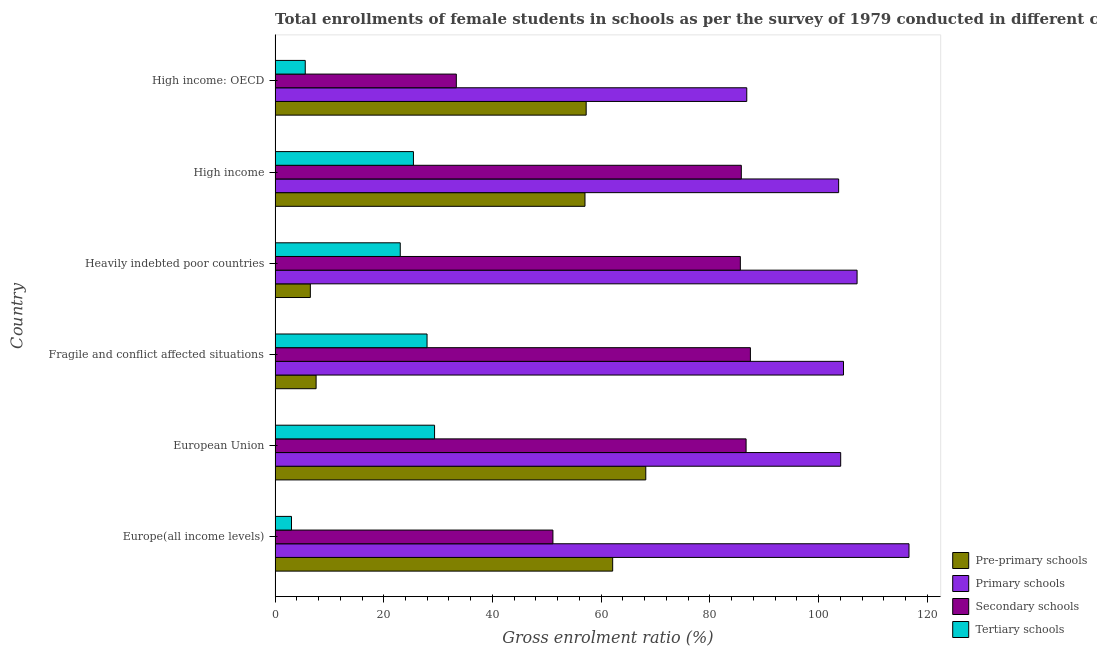Are the number of bars on each tick of the Y-axis equal?
Provide a short and direct response. Yes. How many bars are there on the 3rd tick from the bottom?
Give a very brief answer. 4. What is the label of the 4th group of bars from the top?
Ensure brevity in your answer.  Fragile and conflict affected situations. What is the gross enrolment ratio(female) in secondary schools in High income?
Ensure brevity in your answer.  85.79. Across all countries, what is the maximum gross enrolment ratio(female) in primary schools?
Give a very brief answer. 116.64. Across all countries, what is the minimum gross enrolment ratio(female) in pre-primary schools?
Keep it short and to the point. 6.49. In which country was the gross enrolment ratio(female) in primary schools minimum?
Provide a succinct answer. High income: OECD. What is the total gross enrolment ratio(female) in secondary schools in the graph?
Provide a succinct answer. 430.01. What is the difference between the gross enrolment ratio(female) in primary schools in Heavily indebted poor countries and that in High income?
Give a very brief answer. 3.39. What is the difference between the gross enrolment ratio(female) in secondary schools in High income: OECD and the gross enrolment ratio(female) in primary schools in Fragile and conflict affected situations?
Provide a succinct answer. -71.24. What is the average gross enrolment ratio(female) in pre-primary schools per country?
Provide a succinct answer. 43.11. What is the difference between the gross enrolment ratio(female) in secondary schools and gross enrolment ratio(female) in pre-primary schools in Heavily indebted poor countries?
Keep it short and to the point. 79.12. What is the ratio of the gross enrolment ratio(female) in pre-primary schools in Europe(all income levels) to that in Fragile and conflict affected situations?
Offer a terse response. 8.23. Is the difference between the gross enrolment ratio(female) in pre-primary schools in Fragile and conflict affected situations and High income greater than the difference between the gross enrolment ratio(female) in primary schools in Fragile and conflict affected situations and High income?
Your response must be concise. No. What is the difference between the highest and the second highest gross enrolment ratio(female) in pre-primary schools?
Your answer should be very brief. 6.09. What is the difference between the highest and the lowest gross enrolment ratio(female) in secondary schools?
Make the answer very short. 54.11. In how many countries, is the gross enrolment ratio(female) in secondary schools greater than the average gross enrolment ratio(female) in secondary schools taken over all countries?
Keep it short and to the point. 4. Is the sum of the gross enrolment ratio(female) in primary schools in Fragile and conflict affected situations and Heavily indebted poor countries greater than the maximum gross enrolment ratio(female) in tertiary schools across all countries?
Give a very brief answer. Yes. Is it the case that in every country, the sum of the gross enrolment ratio(female) in secondary schools and gross enrolment ratio(female) in tertiary schools is greater than the sum of gross enrolment ratio(female) in pre-primary schools and gross enrolment ratio(female) in primary schools?
Keep it short and to the point. No. What does the 4th bar from the top in Heavily indebted poor countries represents?
Offer a terse response. Pre-primary schools. What does the 2nd bar from the bottom in High income represents?
Provide a short and direct response. Primary schools. Is it the case that in every country, the sum of the gross enrolment ratio(female) in pre-primary schools and gross enrolment ratio(female) in primary schools is greater than the gross enrolment ratio(female) in secondary schools?
Offer a very short reply. Yes. What is the difference between two consecutive major ticks on the X-axis?
Give a very brief answer. 20. Does the graph contain any zero values?
Keep it short and to the point. No. Where does the legend appear in the graph?
Your answer should be compact. Bottom right. How many legend labels are there?
Make the answer very short. 4. How are the legend labels stacked?
Your answer should be very brief. Vertical. What is the title of the graph?
Provide a short and direct response. Total enrollments of female students in schools as per the survey of 1979 conducted in different countries. What is the label or title of the X-axis?
Offer a very short reply. Gross enrolment ratio (%). What is the Gross enrolment ratio (%) of Pre-primary schools in Europe(all income levels)?
Provide a short and direct response. 62.12. What is the Gross enrolment ratio (%) in Primary schools in Europe(all income levels)?
Your answer should be compact. 116.64. What is the Gross enrolment ratio (%) of Secondary schools in Europe(all income levels)?
Keep it short and to the point. 51.13. What is the Gross enrolment ratio (%) in Tertiary schools in Europe(all income levels)?
Provide a short and direct response. 3.02. What is the Gross enrolment ratio (%) of Pre-primary schools in European Union?
Keep it short and to the point. 68.21. What is the Gross enrolment ratio (%) of Primary schools in European Union?
Ensure brevity in your answer.  104.08. What is the Gross enrolment ratio (%) of Secondary schools in European Union?
Keep it short and to the point. 86.67. What is the Gross enrolment ratio (%) in Tertiary schools in European Union?
Keep it short and to the point. 29.34. What is the Gross enrolment ratio (%) in Pre-primary schools in Fragile and conflict affected situations?
Your answer should be very brief. 7.55. What is the Gross enrolment ratio (%) of Primary schools in Fragile and conflict affected situations?
Ensure brevity in your answer.  104.59. What is the Gross enrolment ratio (%) of Secondary schools in Fragile and conflict affected situations?
Make the answer very short. 87.46. What is the Gross enrolment ratio (%) of Tertiary schools in Fragile and conflict affected situations?
Make the answer very short. 27.96. What is the Gross enrolment ratio (%) of Pre-primary schools in Heavily indebted poor countries?
Ensure brevity in your answer.  6.49. What is the Gross enrolment ratio (%) of Primary schools in Heavily indebted poor countries?
Your answer should be very brief. 107.09. What is the Gross enrolment ratio (%) of Secondary schools in Heavily indebted poor countries?
Offer a very short reply. 85.61. What is the Gross enrolment ratio (%) of Tertiary schools in Heavily indebted poor countries?
Make the answer very short. 23.03. What is the Gross enrolment ratio (%) in Pre-primary schools in High income?
Your answer should be compact. 57.02. What is the Gross enrolment ratio (%) in Primary schools in High income?
Provide a short and direct response. 103.7. What is the Gross enrolment ratio (%) of Secondary schools in High income?
Provide a short and direct response. 85.79. What is the Gross enrolment ratio (%) of Tertiary schools in High income?
Ensure brevity in your answer.  25.46. What is the Gross enrolment ratio (%) of Pre-primary schools in High income: OECD?
Give a very brief answer. 57.24. What is the Gross enrolment ratio (%) of Primary schools in High income: OECD?
Keep it short and to the point. 86.79. What is the Gross enrolment ratio (%) in Secondary schools in High income: OECD?
Your answer should be very brief. 33.35. What is the Gross enrolment ratio (%) in Tertiary schools in High income: OECD?
Offer a very short reply. 5.55. Across all countries, what is the maximum Gross enrolment ratio (%) of Pre-primary schools?
Your answer should be compact. 68.21. Across all countries, what is the maximum Gross enrolment ratio (%) in Primary schools?
Offer a very short reply. 116.64. Across all countries, what is the maximum Gross enrolment ratio (%) of Secondary schools?
Keep it short and to the point. 87.46. Across all countries, what is the maximum Gross enrolment ratio (%) of Tertiary schools?
Provide a succinct answer. 29.34. Across all countries, what is the minimum Gross enrolment ratio (%) in Pre-primary schools?
Ensure brevity in your answer.  6.49. Across all countries, what is the minimum Gross enrolment ratio (%) in Primary schools?
Keep it short and to the point. 86.79. Across all countries, what is the minimum Gross enrolment ratio (%) in Secondary schools?
Your response must be concise. 33.35. Across all countries, what is the minimum Gross enrolment ratio (%) in Tertiary schools?
Provide a short and direct response. 3.02. What is the total Gross enrolment ratio (%) of Pre-primary schools in the graph?
Keep it short and to the point. 258.64. What is the total Gross enrolment ratio (%) in Primary schools in the graph?
Give a very brief answer. 622.9. What is the total Gross enrolment ratio (%) of Secondary schools in the graph?
Your answer should be compact. 430.01. What is the total Gross enrolment ratio (%) in Tertiary schools in the graph?
Your response must be concise. 114.37. What is the difference between the Gross enrolment ratio (%) of Pre-primary schools in Europe(all income levels) and that in European Union?
Offer a terse response. -6.09. What is the difference between the Gross enrolment ratio (%) of Primary schools in Europe(all income levels) and that in European Union?
Provide a short and direct response. 12.57. What is the difference between the Gross enrolment ratio (%) in Secondary schools in Europe(all income levels) and that in European Union?
Ensure brevity in your answer.  -35.54. What is the difference between the Gross enrolment ratio (%) in Tertiary schools in Europe(all income levels) and that in European Union?
Ensure brevity in your answer.  -26.32. What is the difference between the Gross enrolment ratio (%) in Pre-primary schools in Europe(all income levels) and that in Fragile and conflict affected situations?
Give a very brief answer. 54.57. What is the difference between the Gross enrolment ratio (%) of Primary schools in Europe(all income levels) and that in Fragile and conflict affected situations?
Your answer should be very brief. 12.05. What is the difference between the Gross enrolment ratio (%) in Secondary schools in Europe(all income levels) and that in Fragile and conflict affected situations?
Give a very brief answer. -36.34. What is the difference between the Gross enrolment ratio (%) in Tertiary schools in Europe(all income levels) and that in Fragile and conflict affected situations?
Provide a succinct answer. -24.94. What is the difference between the Gross enrolment ratio (%) of Pre-primary schools in Europe(all income levels) and that in Heavily indebted poor countries?
Your response must be concise. 55.63. What is the difference between the Gross enrolment ratio (%) of Primary schools in Europe(all income levels) and that in Heavily indebted poor countries?
Your answer should be very brief. 9.55. What is the difference between the Gross enrolment ratio (%) in Secondary schools in Europe(all income levels) and that in Heavily indebted poor countries?
Offer a very short reply. -34.48. What is the difference between the Gross enrolment ratio (%) of Tertiary schools in Europe(all income levels) and that in Heavily indebted poor countries?
Provide a short and direct response. -20.01. What is the difference between the Gross enrolment ratio (%) of Pre-primary schools in Europe(all income levels) and that in High income?
Provide a succinct answer. 5.1. What is the difference between the Gross enrolment ratio (%) in Primary schools in Europe(all income levels) and that in High income?
Keep it short and to the point. 12.95. What is the difference between the Gross enrolment ratio (%) in Secondary schools in Europe(all income levels) and that in High income?
Offer a very short reply. -34.66. What is the difference between the Gross enrolment ratio (%) in Tertiary schools in Europe(all income levels) and that in High income?
Offer a very short reply. -22.44. What is the difference between the Gross enrolment ratio (%) in Pre-primary schools in Europe(all income levels) and that in High income: OECD?
Offer a very short reply. 4.88. What is the difference between the Gross enrolment ratio (%) in Primary schools in Europe(all income levels) and that in High income: OECD?
Your answer should be compact. 29.85. What is the difference between the Gross enrolment ratio (%) of Secondary schools in Europe(all income levels) and that in High income: OECD?
Make the answer very short. 17.78. What is the difference between the Gross enrolment ratio (%) in Tertiary schools in Europe(all income levels) and that in High income: OECD?
Your answer should be very brief. -2.53. What is the difference between the Gross enrolment ratio (%) in Pre-primary schools in European Union and that in Fragile and conflict affected situations?
Make the answer very short. 60.66. What is the difference between the Gross enrolment ratio (%) of Primary schools in European Union and that in Fragile and conflict affected situations?
Make the answer very short. -0.52. What is the difference between the Gross enrolment ratio (%) in Secondary schools in European Union and that in Fragile and conflict affected situations?
Your response must be concise. -0.79. What is the difference between the Gross enrolment ratio (%) of Tertiary schools in European Union and that in Fragile and conflict affected situations?
Keep it short and to the point. 1.38. What is the difference between the Gross enrolment ratio (%) in Pre-primary schools in European Union and that in Heavily indebted poor countries?
Your answer should be compact. 61.72. What is the difference between the Gross enrolment ratio (%) of Primary schools in European Union and that in Heavily indebted poor countries?
Ensure brevity in your answer.  -3.02. What is the difference between the Gross enrolment ratio (%) of Secondary schools in European Union and that in Heavily indebted poor countries?
Offer a very short reply. 1.06. What is the difference between the Gross enrolment ratio (%) of Tertiary schools in European Union and that in Heavily indebted poor countries?
Provide a short and direct response. 6.31. What is the difference between the Gross enrolment ratio (%) in Pre-primary schools in European Union and that in High income?
Your answer should be very brief. 11.19. What is the difference between the Gross enrolment ratio (%) in Primary schools in European Union and that in High income?
Your answer should be very brief. 0.38. What is the difference between the Gross enrolment ratio (%) in Secondary schools in European Union and that in High income?
Offer a very short reply. 0.88. What is the difference between the Gross enrolment ratio (%) of Tertiary schools in European Union and that in High income?
Offer a terse response. 3.89. What is the difference between the Gross enrolment ratio (%) of Pre-primary schools in European Union and that in High income: OECD?
Ensure brevity in your answer.  10.97. What is the difference between the Gross enrolment ratio (%) of Primary schools in European Union and that in High income: OECD?
Offer a terse response. 17.28. What is the difference between the Gross enrolment ratio (%) of Secondary schools in European Union and that in High income: OECD?
Your answer should be compact. 53.32. What is the difference between the Gross enrolment ratio (%) of Tertiary schools in European Union and that in High income: OECD?
Make the answer very short. 23.79. What is the difference between the Gross enrolment ratio (%) in Pre-primary schools in Fragile and conflict affected situations and that in Heavily indebted poor countries?
Provide a short and direct response. 1.06. What is the difference between the Gross enrolment ratio (%) of Primary schools in Fragile and conflict affected situations and that in Heavily indebted poor countries?
Your response must be concise. -2.5. What is the difference between the Gross enrolment ratio (%) in Secondary schools in Fragile and conflict affected situations and that in Heavily indebted poor countries?
Provide a succinct answer. 1.85. What is the difference between the Gross enrolment ratio (%) of Tertiary schools in Fragile and conflict affected situations and that in Heavily indebted poor countries?
Offer a very short reply. 4.93. What is the difference between the Gross enrolment ratio (%) of Pre-primary schools in Fragile and conflict affected situations and that in High income?
Your answer should be very brief. -49.48. What is the difference between the Gross enrolment ratio (%) of Primary schools in Fragile and conflict affected situations and that in High income?
Provide a short and direct response. 0.89. What is the difference between the Gross enrolment ratio (%) in Secondary schools in Fragile and conflict affected situations and that in High income?
Offer a very short reply. 1.67. What is the difference between the Gross enrolment ratio (%) of Tertiary schools in Fragile and conflict affected situations and that in High income?
Your answer should be compact. 2.5. What is the difference between the Gross enrolment ratio (%) of Pre-primary schools in Fragile and conflict affected situations and that in High income: OECD?
Provide a succinct answer. -49.69. What is the difference between the Gross enrolment ratio (%) in Primary schools in Fragile and conflict affected situations and that in High income: OECD?
Give a very brief answer. 17.8. What is the difference between the Gross enrolment ratio (%) in Secondary schools in Fragile and conflict affected situations and that in High income: OECD?
Offer a very short reply. 54.11. What is the difference between the Gross enrolment ratio (%) in Tertiary schools in Fragile and conflict affected situations and that in High income: OECD?
Your answer should be compact. 22.41. What is the difference between the Gross enrolment ratio (%) of Pre-primary schools in Heavily indebted poor countries and that in High income?
Give a very brief answer. -50.54. What is the difference between the Gross enrolment ratio (%) of Primary schools in Heavily indebted poor countries and that in High income?
Ensure brevity in your answer.  3.39. What is the difference between the Gross enrolment ratio (%) in Secondary schools in Heavily indebted poor countries and that in High income?
Make the answer very short. -0.18. What is the difference between the Gross enrolment ratio (%) of Tertiary schools in Heavily indebted poor countries and that in High income?
Keep it short and to the point. -2.43. What is the difference between the Gross enrolment ratio (%) in Pre-primary schools in Heavily indebted poor countries and that in High income: OECD?
Your answer should be very brief. -50.75. What is the difference between the Gross enrolment ratio (%) in Primary schools in Heavily indebted poor countries and that in High income: OECD?
Keep it short and to the point. 20.3. What is the difference between the Gross enrolment ratio (%) of Secondary schools in Heavily indebted poor countries and that in High income: OECD?
Ensure brevity in your answer.  52.26. What is the difference between the Gross enrolment ratio (%) in Tertiary schools in Heavily indebted poor countries and that in High income: OECD?
Make the answer very short. 17.48. What is the difference between the Gross enrolment ratio (%) in Pre-primary schools in High income and that in High income: OECD?
Give a very brief answer. -0.22. What is the difference between the Gross enrolment ratio (%) of Primary schools in High income and that in High income: OECD?
Provide a succinct answer. 16.91. What is the difference between the Gross enrolment ratio (%) of Secondary schools in High income and that in High income: OECD?
Ensure brevity in your answer.  52.44. What is the difference between the Gross enrolment ratio (%) in Tertiary schools in High income and that in High income: OECD?
Provide a succinct answer. 19.91. What is the difference between the Gross enrolment ratio (%) in Pre-primary schools in Europe(all income levels) and the Gross enrolment ratio (%) in Primary schools in European Union?
Give a very brief answer. -41.96. What is the difference between the Gross enrolment ratio (%) of Pre-primary schools in Europe(all income levels) and the Gross enrolment ratio (%) of Secondary schools in European Union?
Your answer should be very brief. -24.55. What is the difference between the Gross enrolment ratio (%) in Pre-primary schools in Europe(all income levels) and the Gross enrolment ratio (%) in Tertiary schools in European Union?
Keep it short and to the point. 32.78. What is the difference between the Gross enrolment ratio (%) in Primary schools in Europe(all income levels) and the Gross enrolment ratio (%) in Secondary schools in European Union?
Provide a short and direct response. 29.98. What is the difference between the Gross enrolment ratio (%) of Primary schools in Europe(all income levels) and the Gross enrolment ratio (%) of Tertiary schools in European Union?
Your answer should be very brief. 87.3. What is the difference between the Gross enrolment ratio (%) in Secondary schools in Europe(all income levels) and the Gross enrolment ratio (%) in Tertiary schools in European Union?
Your answer should be very brief. 21.78. What is the difference between the Gross enrolment ratio (%) of Pre-primary schools in Europe(all income levels) and the Gross enrolment ratio (%) of Primary schools in Fragile and conflict affected situations?
Ensure brevity in your answer.  -42.47. What is the difference between the Gross enrolment ratio (%) of Pre-primary schools in Europe(all income levels) and the Gross enrolment ratio (%) of Secondary schools in Fragile and conflict affected situations?
Provide a short and direct response. -25.34. What is the difference between the Gross enrolment ratio (%) of Pre-primary schools in Europe(all income levels) and the Gross enrolment ratio (%) of Tertiary schools in Fragile and conflict affected situations?
Make the answer very short. 34.16. What is the difference between the Gross enrolment ratio (%) of Primary schools in Europe(all income levels) and the Gross enrolment ratio (%) of Secondary schools in Fragile and conflict affected situations?
Your answer should be compact. 29.18. What is the difference between the Gross enrolment ratio (%) in Primary schools in Europe(all income levels) and the Gross enrolment ratio (%) in Tertiary schools in Fragile and conflict affected situations?
Keep it short and to the point. 88.68. What is the difference between the Gross enrolment ratio (%) in Secondary schools in Europe(all income levels) and the Gross enrolment ratio (%) in Tertiary schools in Fragile and conflict affected situations?
Your answer should be very brief. 23.16. What is the difference between the Gross enrolment ratio (%) in Pre-primary schools in Europe(all income levels) and the Gross enrolment ratio (%) in Primary schools in Heavily indebted poor countries?
Give a very brief answer. -44.97. What is the difference between the Gross enrolment ratio (%) in Pre-primary schools in Europe(all income levels) and the Gross enrolment ratio (%) in Secondary schools in Heavily indebted poor countries?
Your response must be concise. -23.49. What is the difference between the Gross enrolment ratio (%) in Pre-primary schools in Europe(all income levels) and the Gross enrolment ratio (%) in Tertiary schools in Heavily indebted poor countries?
Provide a short and direct response. 39.09. What is the difference between the Gross enrolment ratio (%) in Primary schools in Europe(all income levels) and the Gross enrolment ratio (%) in Secondary schools in Heavily indebted poor countries?
Your answer should be compact. 31.03. What is the difference between the Gross enrolment ratio (%) of Primary schools in Europe(all income levels) and the Gross enrolment ratio (%) of Tertiary schools in Heavily indebted poor countries?
Offer a very short reply. 93.61. What is the difference between the Gross enrolment ratio (%) in Secondary schools in Europe(all income levels) and the Gross enrolment ratio (%) in Tertiary schools in Heavily indebted poor countries?
Offer a terse response. 28.09. What is the difference between the Gross enrolment ratio (%) in Pre-primary schools in Europe(all income levels) and the Gross enrolment ratio (%) in Primary schools in High income?
Your answer should be very brief. -41.58. What is the difference between the Gross enrolment ratio (%) in Pre-primary schools in Europe(all income levels) and the Gross enrolment ratio (%) in Secondary schools in High income?
Your answer should be very brief. -23.67. What is the difference between the Gross enrolment ratio (%) in Pre-primary schools in Europe(all income levels) and the Gross enrolment ratio (%) in Tertiary schools in High income?
Your answer should be very brief. 36.66. What is the difference between the Gross enrolment ratio (%) in Primary schools in Europe(all income levels) and the Gross enrolment ratio (%) in Secondary schools in High income?
Provide a succinct answer. 30.86. What is the difference between the Gross enrolment ratio (%) in Primary schools in Europe(all income levels) and the Gross enrolment ratio (%) in Tertiary schools in High income?
Make the answer very short. 91.19. What is the difference between the Gross enrolment ratio (%) of Secondary schools in Europe(all income levels) and the Gross enrolment ratio (%) of Tertiary schools in High income?
Make the answer very short. 25.67. What is the difference between the Gross enrolment ratio (%) in Pre-primary schools in Europe(all income levels) and the Gross enrolment ratio (%) in Primary schools in High income: OECD?
Offer a terse response. -24.67. What is the difference between the Gross enrolment ratio (%) in Pre-primary schools in Europe(all income levels) and the Gross enrolment ratio (%) in Secondary schools in High income: OECD?
Keep it short and to the point. 28.77. What is the difference between the Gross enrolment ratio (%) in Pre-primary schools in Europe(all income levels) and the Gross enrolment ratio (%) in Tertiary schools in High income: OECD?
Offer a terse response. 56.57. What is the difference between the Gross enrolment ratio (%) of Primary schools in Europe(all income levels) and the Gross enrolment ratio (%) of Secondary schools in High income: OECD?
Your answer should be compact. 83.3. What is the difference between the Gross enrolment ratio (%) of Primary schools in Europe(all income levels) and the Gross enrolment ratio (%) of Tertiary schools in High income: OECD?
Keep it short and to the point. 111.09. What is the difference between the Gross enrolment ratio (%) in Secondary schools in Europe(all income levels) and the Gross enrolment ratio (%) in Tertiary schools in High income: OECD?
Keep it short and to the point. 45.57. What is the difference between the Gross enrolment ratio (%) of Pre-primary schools in European Union and the Gross enrolment ratio (%) of Primary schools in Fragile and conflict affected situations?
Offer a very short reply. -36.38. What is the difference between the Gross enrolment ratio (%) of Pre-primary schools in European Union and the Gross enrolment ratio (%) of Secondary schools in Fragile and conflict affected situations?
Your answer should be compact. -19.25. What is the difference between the Gross enrolment ratio (%) in Pre-primary schools in European Union and the Gross enrolment ratio (%) in Tertiary schools in Fragile and conflict affected situations?
Your response must be concise. 40.25. What is the difference between the Gross enrolment ratio (%) of Primary schools in European Union and the Gross enrolment ratio (%) of Secondary schools in Fragile and conflict affected situations?
Your response must be concise. 16.61. What is the difference between the Gross enrolment ratio (%) of Primary schools in European Union and the Gross enrolment ratio (%) of Tertiary schools in Fragile and conflict affected situations?
Provide a succinct answer. 76.11. What is the difference between the Gross enrolment ratio (%) in Secondary schools in European Union and the Gross enrolment ratio (%) in Tertiary schools in Fragile and conflict affected situations?
Offer a very short reply. 58.7. What is the difference between the Gross enrolment ratio (%) in Pre-primary schools in European Union and the Gross enrolment ratio (%) in Primary schools in Heavily indebted poor countries?
Give a very brief answer. -38.88. What is the difference between the Gross enrolment ratio (%) of Pre-primary schools in European Union and the Gross enrolment ratio (%) of Secondary schools in Heavily indebted poor countries?
Offer a terse response. -17.4. What is the difference between the Gross enrolment ratio (%) of Pre-primary schools in European Union and the Gross enrolment ratio (%) of Tertiary schools in Heavily indebted poor countries?
Offer a terse response. 45.18. What is the difference between the Gross enrolment ratio (%) of Primary schools in European Union and the Gross enrolment ratio (%) of Secondary schools in Heavily indebted poor countries?
Make the answer very short. 18.46. What is the difference between the Gross enrolment ratio (%) of Primary schools in European Union and the Gross enrolment ratio (%) of Tertiary schools in Heavily indebted poor countries?
Your response must be concise. 81.04. What is the difference between the Gross enrolment ratio (%) of Secondary schools in European Union and the Gross enrolment ratio (%) of Tertiary schools in Heavily indebted poor countries?
Ensure brevity in your answer.  63.64. What is the difference between the Gross enrolment ratio (%) in Pre-primary schools in European Union and the Gross enrolment ratio (%) in Primary schools in High income?
Offer a very short reply. -35.49. What is the difference between the Gross enrolment ratio (%) of Pre-primary schools in European Union and the Gross enrolment ratio (%) of Secondary schools in High income?
Make the answer very short. -17.58. What is the difference between the Gross enrolment ratio (%) of Pre-primary schools in European Union and the Gross enrolment ratio (%) of Tertiary schools in High income?
Offer a terse response. 42.75. What is the difference between the Gross enrolment ratio (%) in Primary schools in European Union and the Gross enrolment ratio (%) in Secondary schools in High income?
Your response must be concise. 18.29. What is the difference between the Gross enrolment ratio (%) of Primary schools in European Union and the Gross enrolment ratio (%) of Tertiary schools in High income?
Give a very brief answer. 78.62. What is the difference between the Gross enrolment ratio (%) in Secondary schools in European Union and the Gross enrolment ratio (%) in Tertiary schools in High income?
Offer a terse response. 61.21. What is the difference between the Gross enrolment ratio (%) of Pre-primary schools in European Union and the Gross enrolment ratio (%) of Primary schools in High income: OECD?
Give a very brief answer. -18.58. What is the difference between the Gross enrolment ratio (%) of Pre-primary schools in European Union and the Gross enrolment ratio (%) of Secondary schools in High income: OECD?
Offer a terse response. 34.86. What is the difference between the Gross enrolment ratio (%) in Pre-primary schools in European Union and the Gross enrolment ratio (%) in Tertiary schools in High income: OECD?
Make the answer very short. 62.66. What is the difference between the Gross enrolment ratio (%) of Primary schools in European Union and the Gross enrolment ratio (%) of Secondary schools in High income: OECD?
Provide a succinct answer. 70.73. What is the difference between the Gross enrolment ratio (%) of Primary schools in European Union and the Gross enrolment ratio (%) of Tertiary schools in High income: OECD?
Offer a very short reply. 98.52. What is the difference between the Gross enrolment ratio (%) of Secondary schools in European Union and the Gross enrolment ratio (%) of Tertiary schools in High income: OECD?
Your answer should be very brief. 81.12. What is the difference between the Gross enrolment ratio (%) of Pre-primary schools in Fragile and conflict affected situations and the Gross enrolment ratio (%) of Primary schools in Heavily indebted poor countries?
Provide a succinct answer. -99.54. What is the difference between the Gross enrolment ratio (%) in Pre-primary schools in Fragile and conflict affected situations and the Gross enrolment ratio (%) in Secondary schools in Heavily indebted poor countries?
Give a very brief answer. -78.06. What is the difference between the Gross enrolment ratio (%) in Pre-primary schools in Fragile and conflict affected situations and the Gross enrolment ratio (%) in Tertiary schools in Heavily indebted poor countries?
Keep it short and to the point. -15.48. What is the difference between the Gross enrolment ratio (%) in Primary schools in Fragile and conflict affected situations and the Gross enrolment ratio (%) in Secondary schools in Heavily indebted poor countries?
Your response must be concise. 18.98. What is the difference between the Gross enrolment ratio (%) of Primary schools in Fragile and conflict affected situations and the Gross enrolment ratio (%) of Tertiary schools in Heavily indebted poor countries?
Your response must be concise. 81.56. What is the difference between the Gross enrolment ratio (%) in Secondary schools in Fragile and conflict affected situations and the Gross enrolment ratio (%) in Tertiary schools in Heavily indebted poor countries?
Offer a very short reply. 64.43. What is the difference between the Gross enrolment ratio (%) of Pre-primary schools in Fragile and conflict affected situations and the Gross enrolment ratio (%) of Primary schools in High income?
Keep it short and to the point. -96.15. What is the difference between the Gross enrolment ratio (%) of Pre-primary schools in Fragile and conflict affected situations and the Gross enrolment ratio (%) of Secondary schools in High income?
Give a very brief answer. -78.24. What is the difference between the Gross enrolment ratio (%) in Pre-primary schools in Fragile and conflict affected situations and the Gross enrolment ratio (%) in Tertiary schools in High income?
Ensure brevity in your answer.  -17.91. What is the difference between the Gross enrolment ratio (%) in Primary schools in Fragile and conflict affected situations and the Gross enrolment ratio (%) in Secondary schools in High income?
Your answer should be compact. 18.8. What is the difference between the Gross enrolment ratio (%) of Primary schools in Fragile and conflict affected situations and the Gross enrolment ratio (%) of Tertiary schools in High income?
Ensure brevity in your answer.  79.13. What is the difference between the Gross enrolment ratio (%) of Secondary schools in Fragile and conflict affected situations and the Gross enrolment ratio (%) of Tertiary schools in High income?
Keep it short and to the point. 62. What is the difference between the Gross enrolment ratio (%) in Pre-primary schools in Fragile and conflict affected situations and the Gross enrolment ratio (%) in Primary schools in High income: OECD?
Your answer should be compact. -79.24. What is the difference between the Gross enrolment ratio (%) in Pre-primary schools in Fragile and conflict affected situations and the Gross enrolment ratio (%) in Secondary schools in High income: OECD?
Provide a short and direct response. -25.8. What is the difference between the Gross enrolment ratio (%) of Pre-primary schools in Fragile and conflict affected situations and the Gross enrolment ratio (%) of Tertiary schools in High income: OECD?
Your answer should be very brief. 2. What is the difference between the Gross enrolment ratio (%) in Primary schools in Fragile and conflict affected situations and the Gross enrolment ratio (%) in Secondary schools in High income: OECD?
Keep it short and to the point. 71.24. What is the difference between the Gross enrolment ratio (%) of Primary schools in Fragile and conflict affected situations and the Gross enrolment ratio (%) of Tertiary schools in High income: OECD?
Provide a succinct answer. 99.04. What is the difference between the Gross enrolment ratio (%) in Secondary schools in Fragile and conflict affected situations and the Gross enrolment ratio (%) in Tertiary schools in High income: OECD?
Offer a very short reply. 81.91. What is the difference between the Gross enrolment ratio (%) of Pre-primary schools in Heavily indebted poor countries and the Gross enrolment ratio (%) of Primary schools in High income?
Offer a very short reply. -97.21. What is the difference between the Gross enrolment ratio (%) in Pre-primary schools in Heavily indebted poor countries and the Gross enrolment ratio (%) in Secondary schools in High income?
Offer a very short reply. -79.3. What is the difference between the Gross enrolment ratio (%) in Pre-primary schools in Heavily indebted poor countries and the Gross enrolment ratio (%) in Tertiary schools in High income?
Ensure brevity in your answer.  -18.97. What is the difference between the Gross enrolment ratio (%) of Primary schools in Heavily indebted poor countries and the Gross enrolment ratio (%) of Secondary schools in High income?
Your answer should be compact. 21.3. What is the difference between the Gross enrolment ratio (%) in Primary schools in Heavily indebted poor countries and the Gross enrolment ratio (%) in Tertiary schools in High income?
Provide a short and direct response. 81.63. What is the difference between the Gross enrolment ratio (%) in Secondary schools in Heavily indebted poor countries and the Gross enrolment ratio (%) in Tertiary schools in High income?
Provide a succinct answer. 60.15. What is the difference between the Gross enrolment ratio (%) of Pre-primary schools in Heavily indebted poor countries and the Gross enrolment ratio (%) of Primary schools in High income: OECD?
Make the answer very short. -80.3. What is the difference between the Gross enrolment ratio (%) of Pre-primary schools in Heavily indebted poor countries and the Gross enrolment ratio (%) of Secondary schools in High income: OECD?
Offer a terse response. -26.86. What is the difference between the Gross enrolment ratio (%) in Pre-primary schools in Heavily indebted poor countries and the Gross enrolment ratio (%) in Tertiary schools in High income: OECD?
Make the answer very short. 0.94. What is the difference between the Gross enrolment ratio (%) in Primary schools in Heavily indebted poor countries and the Gross enrolment ratio (%) in Secondary schools in High income: OECD?
Ensure brevity in your answer.  73.74. What is the difference between the Gross enrolment ratio (%) in Primary schools in Heavily indebted poor countries and the Gross enrolment ratio (%) in Tertiary schools in High income: OECD?
Give a very brief answer. 101.54. What is the difference between the Gross enrolment ratio (%) of Secondary schools in Heavily indebted poor countries and the Gross enrolment ratio (%) of Tertiary schools in High income: OECD?
Your response must be concise. 80.06. What is the difference between the Gross enrolment ratio (%) of Pre-primary schools in High income and the Gross enrolment ratio (%) of Primary schools in High income: OECD?
Keep it short and to the point. -29.77. What is the difference between the Gross enrolment ratio (%) in Pre-primary schools in High income and the Gross enrolment ratio (%) in Secondary schools in High income: OECD?
Make the answer very short. 23.67. What is the difference between the Gross enrolment ratio (%) of Pre-primary schools in High income and the Gross enrolment ratio (%) of Tertiary schools in High income: OECD?
Keep it short and to the point. 51.47. What is the difference between the Gross enrolment ratio (%) in Primary schools in High income and the Gross enrolment ratio (%) in Secondary schools in High income: OECD?
Provide a succinct answer. 70.35. What is the difference between the Gross enrolment ratio (%) of Primary schools in High income and the Gross enrolment ratio (%) of Tertiary schools in High income: OECD?
Offer a very short reply. 98.15. What is the difference between the Gross enrolment ratio (%) of Secondary schools in High income and the Gross enrolment ratio (%) of Tertiary schools in High income: OECD?
Offer a very short reply. 80.24. What is the average Gross enrolment ratio (%) of Pre-primary schools per country?
Keep it short and to the point. 43.11. What is the average Gross enrolment ratio (%) in Primary schools per country?
Your answer should be compact. 103.82. What is the average Gross enrolment ratio (%) in Secondary schools per country?
Keep it short and to the point. 71.67. What is the average Gross enrolment ratio (%) in Tertiary schools per country?
Ensure brevity in your answer.  19.06. What is the difference between the Gross enrolment ratio (%) in Pre-primary schools and Gross enrolment ratio (%) in Primary schools in Europe(all income levels)?
Provide a short and direct response. -54.53. What is the difference between the Gross enrolment ratio (%) of Pre-primary schools and Gross enrolment ratio (%) of Secondary schools in Europe(all income levels)?
Your answer should be compact. 10.99. What is the difference between the Gross enrolment ratio (%) in Pre-primary schools and Gross enrolment ratio (%) in Tertiary schools in Europe(all income levels)?
Provide a succinct answer. 59.1. What is the difference between the Gross enrolment ratio (%) of Primary schools and Gross enrolment ratio (%) of Secondary schools in Europe(all income levels)?
Your answer should be very brief. 65.52. What is the difference between the Gross enrolment ratio (%) of Primary schools and Gross enrolment ratio (%) of Tertiary schools in Europe(all income levels)?
Give a very brief answer. 113.62. What is the difference between the Gross enrolment ratio (%) in Secondary schools and Gross enrolment ratio (%) in Tertiary schools in Europe(all income levels)?
Make the answer very short. 48.1. What is the difference between the Gross enrolment ratio (%) of Pre-primary schools and Gross enrolment ratio (%) of Primary schools in European Union?
Your answer should be very brief. -35.86. What is the difference between the Gross enrolment ratio (%) of Pre-primary schools and Gross enrolment ratio (%) of Secondary schools in European Union?
Provide a short and direct response. -18.46. What is the difference between the Gross enrolment ratio (%) in Pre-primary schools and Gross enrolment ratio (%) in Tertiary schools in European Union?
Ensure brevity in your answer.  38.87. What is the difference between the Gross enrolment ratio (%) of Primary schools and Gross enrolment ratio (%) of Secondary schools in European Union?
Make the answer very short. 17.41. What is the difference between the Gross enrolment ratio (%) of Primary schools and Gross enrolment ratio (%) of Tertiary schools in European Union?
Make the answer very short. 74.73. What is the difference between the Gross enrolment ratio (%) in Secondary schools and Gross enrolment ratio (%) in Tertiary schools in European Union?
Your answer should be very brief. 57.32. What is the difference between the Gross enrolment ratio (%) of Pre-primary schools and Gross enrolment ratio (%) of Primary schools in Fragile and conflict affected situations?
Give a very brief answer. -97.04. What is the difference between the Gross enrolment ratio (%) of Pre-primary schools and Gross enrolment ratio (%) of Secondary schools in Fragile and conflict affected situations?
Your response must be concise. -79.91. What is the difference between the Gross enrolment ratio (%) of Pre-primary schools and Gross enrolment ratio (%) of Tertiary schools in Fragile and conflict affected situations?
Keep it short and to the point. -20.41. What is the difference between the Gross enrolment ratio (%) of Primary schools and Gross enrolment ratio (%) of Secondary schools in Fragile and conflict affected situations?
Provide a succinct answer. 17.13. What is the difference between the Gross enrolment ratio (%) of Primary schools and Gross enrolment ratio (%) of Tertiary schools in Fragile and conflict affected situations?
Give a very brief answer. 76.63. What is the difference between the Gross enrolment ratio (%) in Secondary schools and Gross enrolment ratio (%) in Tertiary schools in Fragile and conflict affected situations?
Your answer should be compact. 59.5. What is the difference between the Gross enrolment ratio (%) in Pre-primary schools and Gross enrolment ratio (%) in Primary schools in Heavily indebted poor countries?
Keep it short and to the point. -100.6. What is the difference between the Gross enrolment ratio (%) of Pre-primary schools and Gross enrolment ratio (%) of Secondary schools in Heavily indebted poor countries?
Offer a terse response. -79.12. What is the difference between the Gross enrolment ratio (%) in Pre-primary schools and Gross enrolment ratio (%) in Tertiary schools in Heavily indebted poor countries?
Your answer should be very brief. -16.54. What is the difference between the Gross enrolment ratio (%) in Primary schools and Gross enrolment ratio (%) in Secondary schools in Heavily indebted poor countries?
Your answer should be very brief. 21.48. What is the difference between the Gross enrolment ratio (%) in Primary schools and Gross enrolment ratio (%) in Tertiary schools in Heavily indebted poor countries?
Provide a succinct answer. 84.06. What is the difference between the Gross enrolment ratio (%) of Secondary schools and Gross enrolment ratio (%) of Tertiary schools in Heavily indebted poor countries?
Make the answer very short. 62.58. What is the difference between the Gross enrolment ratio (%) in Pre-primary schools and Gross enrolment ratio (%) in Primary schools in High income?
Offer a very short reply. -46.67. What is the difference between the Gross enrolment ratio (%) in Pre-primary schools and Gross enrolment ratio (%) in Secondary schools in High income?
Your answer should be very brief. -28.76. What is the difference between the Gross enrolment ratio (%) in Pre-primary schools and Gross enrolment ratio (%) in Tertiary schools in High income?
Your answer should be very brief. 31.57. What is the difference between the Gross enrolment ratio (%) of Primary schools and Gross enrolment ratio (%) of Secondary schools in High income?
Your response must be concise. 17.91. What is the difference between the Gross enrolment ratio (%) of Primary schools and Gross enrolment ratio (%) of Tertiary schools in High income?
Provide a succinct answer. 78.24. What is the difference between the Gross enrolment ratio (%) of Secondary schools and Gross enrolment ratio (%) of Tertiary schools in High income?
Offer a very short reply. 60.33. What is the difference between the Gross enrolment ratio (%) of Pre-primary schools and Gross enrolment ratio (%) of Primary schools in High income: OECD?
Provide a short and direct response. -29.55. What is the difference between the Gross enrolment ratio (%) of Pre-primary schools and Gross enrolment ratio (%) of Secondary schools in High income: OECD?
Give a very brief answer. 23.89. What is the difference between the Gross enrolment ratio (%) of Pre-primary schools and Gross enrolment ratio (%) of Tertiary schools in High income: OECD?
Keep it short and to the point. 51.69. What is the difference between the Gross enrolment ratio (%) in Primary schools and Gross enrolment ratio (%) in Secondary schools in High income: OECD?
Ensure brevity in your answer.  53.44. What is the difference between the Gross enrolment ratio (%) in Primary schools and Gross enrolment ratio (%) in Tertiary schools in High income: OECD?
Make the answer very short. 81.24. What is the difference between the Gross enrolment ratio (%) of Secondary schools and Gross enrolment ratio (%) of Tertiary schools in High income: OECD?
Ensure brevity in your answer.  27.8. What is the ratio of the Gross enrolment ratio (%) in Pre-primary schools in Europe(all income levels) to that in European Union?
Provide a succinct answer. 0.91. What is the ratio of the Gross enrolment ratio (%) in Primary schools in Europe(all income levels) to that in European Union?
Your response must be concise. 1.12. What is the ratio of the Gross enrolment ratio (%) of Secondary schools in Europe(all income levels) to that in European Union?
Offer a very short reply. 0.59. What is the ratio of the Gross enrolment ratio (%) of Tertiary schools in Europe(all income levels) to that in European Union?
Your answer should be compact. 0.1. What is the ratio of the Gross enrolment ratio (%) in Pre-primary schools in Europe(all income levels) to that in Fragile and conflict affected situations?
Give a very brief answer. 8.23. What is the ratio of the Gross enrolment ratio (%) in Primary schools in Europe(all income levels) to that in Fragile and conflict affected situations?
Ensure brevity in your answer.  1.12. What is the ratio of the Gross enrolment ratio (%) in Secondary schools in Europe(all income levels) to that in Fragile and conflict affected situations?
Offer a terse response. 0.58. What is the ratio of the Gross enrolment ratio (%) in Tertiary schools in Europe(all income levels) to that in Fragile and conflict affected situations?
Give a very brief answer. 0.11. What is the ratio of the Gross enrolment ratio (%) in Pre-primary schools in Europe(all income levels) to that in Heavily indebted poor countries?
Your response must be concise. 9.57. What is the ratio of the Gross enrolment ratio (%) of Primary schools in Europe(all income levels) to that in Heavily indebted poor countries?
Offer a terse response. 1.09. What is the ratio of the Gross enrolment ratio (%) in Secondary schools in Europe(all income levels) to that in Heavily indebted poor countries?
Give a very brief answer. 0.6. What is the ratio of the Gross enrolment ratio (%) of Tertiary schools in Europe(all income levels) to that in Heavily indebted poor countries?
Keep it short and to the point. 0.13. What is the ratio of the Gross enrolment ratio (%) of Pre-primary schools in Europe(all income levels) to that in High income?
Provide a succinct answer. 1.09. What is the ratio of the Gross enrolment ratio (%) in Primary schools in Europe(all income levels) to that in High income?
Give a very brief answer. 1.12. What is the ratio of the Gross enrolment ratio (%) in Secondary schools in Europe(all income levels) to that in High income?
Provide a short and direct response. 0.6. What is the ratio of the Gross enrolment ratio (%) of Tertiary schools in Europe(all income levels) to that in High income?
Offer a very short reply. 0.12. What is the ratio of the Gross enrolment ratio (%) of Pre-primary schools in Europe(all income levels) to that in High income: OECD?
Ensure brevity in your answer.  1.09. What is the ratio of the Gross enrolment ratio (%) of Primary schools in Europe(all income levels) to that in High income: OECD?
Your answer should be compact. 1.34. What is the ratio of the Gross enrolment ratio (%) of Secondary schools in Europe(all income levels) to that in High income: OECD?
Give a very brief answer. 1.53. What is the ratio of the Gross enrolment ratio (%) of Tertiary schools in Europe(all income levels) to that in High income: OECD?
Provide a short and direct response. 0.54. What is the ratio of the Gross enrolment ratio (%) in Pre-primary schools in European Union to that in Fragile and conflict affected situations?
Offer a very short reply. 9.04. What is the ratio of the Gross enrolment ratio (%) in Secondary schools in European Union to that in Fragile and conflict affected situations?
Offer a terse response. 0.99. What is the ratio of the Gross enrolment ratio (%) of Tertiary schools in European Union to that in Fragile and conflict affected situations?
Your answer should be very brief. 1.05. What is the ratio of the Gross enrolment ratio (%) in Pre-primary schools in European Union to that in Heavily indebted poor countries?
Offer a terse response. 10.51. What is the ratio of the Gross enrolment ratio (%) of Primary schools in European Union to that in Heavily indebted poor countries?
Offer a terse response. 0.97. What is the ratio of the Gross enrolment ratio (%) in Secondary schools in European Union to that in Heavily indebted poor countries?
Provide a succinct answer. 1.01. What is the ratio of the Gross enrolment ratio (%) of Tertiary schools in European Union to that in Heavily indebted poor countries?
Your answer should be compact. 1.27. What is the ratio of the Gross enrolment ratio (%) of Pre-primary schools in European Union to that in High income?
Offer a terse response. 1.2. What is the ratio of the Gross enrolment ratio (%) of Secondary schools in European Union to that in High income?
Your answer should be very brief. 1.01. What is the ratio of the Gross enrolment ratio (%) in Tertiary schools in European Union to that in High income?
Ensure brevity in your answer.  1.15. What is the ratio of the Gross enrolment ratio (%) of Pre-primary schools in European Union to that in High income: OECD?
Provide a succinct answer. 1.19. What is the ratio of the Gross enrolment ratio (%) of Primary schools in European Union to that in High income: OECD?
Your answer should be very brief. 1.2. What is the ratio of the Gross enrolment ratio (%) of Secondary schools in European Union to that in High income: OECD?
Your answer should be compact. 2.6. What is the ratio of the Gross enrolment ratio (%) of Tertiary schools in European Union to that in High income: OECD?
Offer a terse response. 5.29. What is the ratio of the Gross enrolment ratio (%) in Pre-primary schools in Fragile and conflict affected situations to that in Heavily indebted poor countries?
Give a very brief answer. 1.16. What is the ratio of the Gross enrolment ratio (%) in Primary schools in Fragile and conflict affected situations to that in Heavily indebted poor countries?
Your response must be concise. 0.98. What is the ratio of the Gross enrolment ratio (%) of Secondary schools in Fragile and conflict affected situations to that in Heavily indebted poor countries?
Keep it short and to the point. 1.02. What is the ratio of the Gross enrolment ratio (%) of Tertiary schools in Fragile and conflict affected situations to that in Heavily indebted poor countries?
Offer a very short reply. 1.21. What is the ratio of the Gross enrolment ratio (%) of Pre-primary schools in Fragile and conflict affected situations to that in High income?
Make the answer very short. 0.13. What is the ratio of the Gross enrolment ratio (%) of Primary schools in Fragile and conflict affected situations to that in High income?
Make the answer very short. 1.01. What is the ratio of the Gross enrolment ratio (%) in Secondary schools in Fragile and conflict affected situations to that in High income?
Your answer should be compact. 1.02. What is the ratio of the Gross enrolment ratio (%) of Tertiary schools in Fragile and conflict affected situations to that in High income?
Keep it short and to the point. 1.1. What is the ratio of the Gross enrolment ratio (%) of Pre-primary schools in Fragile and conflict affected situations to that in High income: OECD?
Provide a succinct answer. 0.13. What is the ratio of the Gross enrolment ratio (%) of Primary schools in Fragile and conflict affected situations to that in High income: OECD?
Provide a short and direct response. 1.21. What is the ratio of the Gross enrolment ratio (%) in Secondary schools in Fragile and conflict affected situations to that in High income: OECD?
Keep it short and to the point. 2.62. What is the ratio of the Gross enrolment ratio (%) in Tertiary schools in Fragile and conflict affected situations to that in High income: OECD?
Ensure brevity in your answer.  5.04. What is the ratio of the Gross enrolment ratio (%) in Pre-primary schools in Heavily indebted poor countries to that in High income?
Offer a terse response. 0.11. What is the ratio of the Gross enrolment ratio (%) in Primary schools in Heavily indebted poor countries to that in High income?
Your answer should be compact. 1.03. What is the ratio of the Gross enrolment ratio (%) in Tertiary schools in Heavily indebted poor countries to that in High income?
Offer a very short reply. 0.9. What is the ratio of the Gross enrolment ratio (%) of Pre-primary schools in Heavily indebted poor countries to that in High income: OECD?
Your answer should be compact. 0.11. What is the ratio of the Gross enrolment ratio (%) in Primary schools in Heavily indebted poor countries to that in High income: OECD?
Make the answer very short. 1.23. What is the ratio of the Gross enrolment ratio (%) of Secondary schools in Heavily indebted poor countries to that in High income: OECD?
Provide a short and direct response. 2.57. What is the ratio of the Gross enrolment ratio (%) in Tertiary schools in Heavily indebted poor countries to that in High income: OECD?
Your response must be concise. 4.15. What is the ratio of the Gross enrolment ratio (%) in Primary schools in High income to that in High income: OECD?
Your response must be concise. 1.19. What is the ratio of the Gross enrolment ratio (%) of Secondary schools in High income to that in High income: OECD?
Your answer should be compact. 2.57. What is the ratio of the Gross enrolment ratio (%) in Tertiary schools in High income to that in High income: OECD?
Offer a terse response. 4.59. What is the difference between the highest and the second highest Gross enrolment ratio (%) of Pre-primary schools?
Offer a very short reply. 6.09. What is the difference between the highest and the second highest Gross enrolment ratio (%) in Primary schools?
Ensure brevity in your answer.  9.55. What is the difference between the highest and the second highest Gross enrolment ratio (%) in Secondary schools?
Your answer should be compact. 0.79. What is the difference between the highest and the second highest Gross enrolment ratio (%) of Tertiary schools?
Provide a succinct answer. 1.38. What is the difference between the highest and the lowest Gross enrolment ratio (%) of Pre-primary schools?
Offer a very short reply. 61.72. What is the difference between the highest and the lowest Gross enrolment ratio (%) of Primary schools?
Offer a terse response. 29.85. What is the difference between the highest and the lowest Gross enrolment ratio (%) of Secondary schools?
Make the answer very short. 54.11. What is the difference between the highest and the lowest Gross enrolment ratio (%) of Tertiary schools?
Provide a short and direct response. 26.32. 